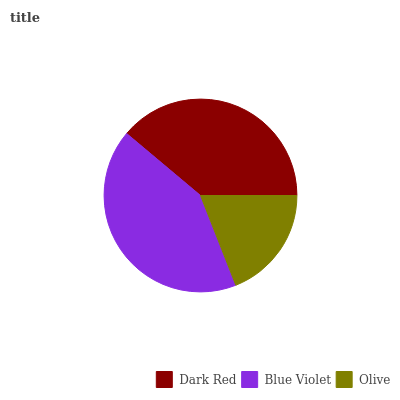Is Olive the minimum?
Answer yes or no. Yes. Is Blue Violet the maximum?
Answer yes or no. Yes. Is Blue Violet the minimum?
Answer yes or no. No. Is Olive the maximum?
Answer yes or no. No. Is Blue Violet greater than Olive?
Answer yes or no. Yes. Is Olive less than Blue Violet?
Answer yes or no. Yes. Is Olive greater than Blue Violet?
Answer yes or no. No. Is Blue Violet less than Olive?
Answer yes or no. No. Is Dark Red the high median?
Answer yes or no. Yes. Is Dark Red the low median?
Answer yes or no. Yes. Is Olive the high median?
Answer yes or no. No. Is Olive the low median?
Answer yes or no. No. 